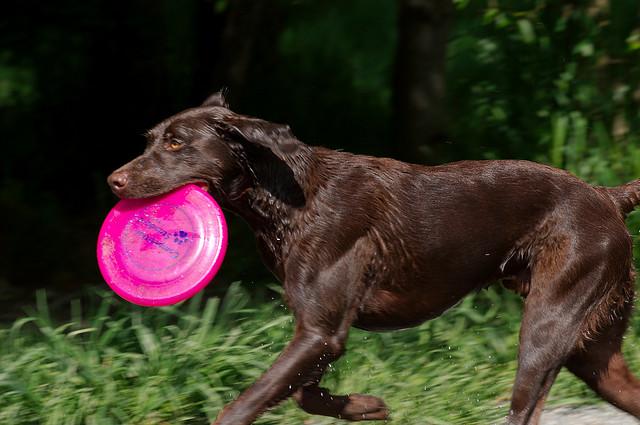What toy does this dog have?
Answer briefly. Frisbee. What animal is this?
Keep it brief. Dog. What color is the frisbee?
Be succinct. Pink. Will the bigger dog get the frisbee?
Be succinct. Yes. Is his paw on the Frisbee?
Concise answer only. No. What is the dog holding?
Be succinct. Frisbee. 